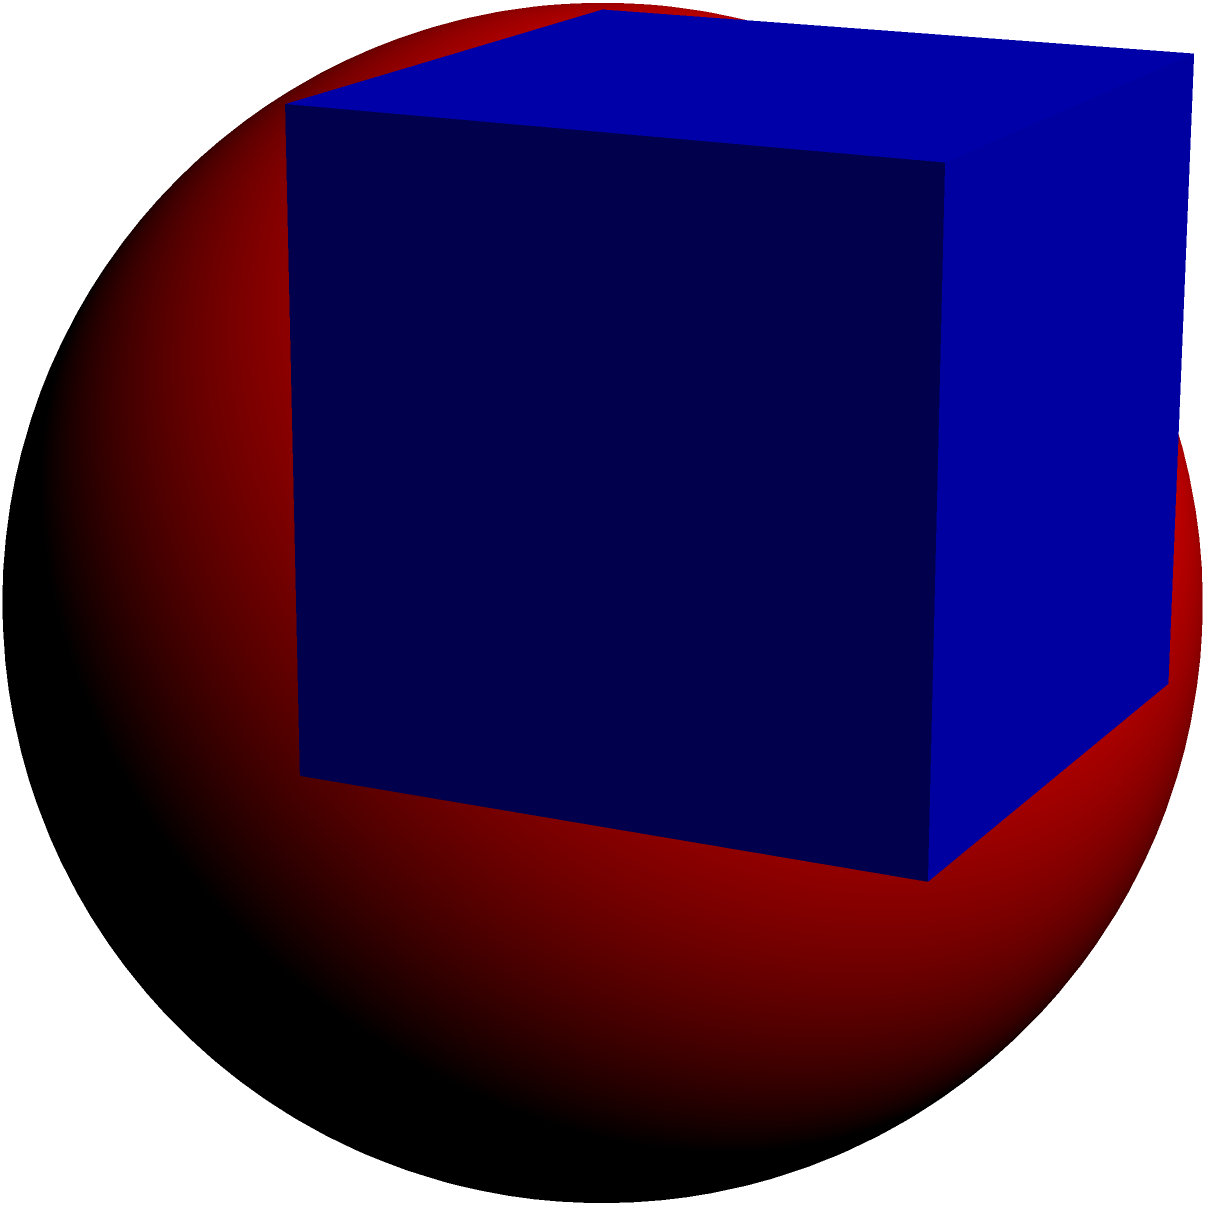As a programmer working on an interactive geometry module, you need to implement a function that calculates the volume of a sphere inscribed in a cube. Given that the edge length of the cube is 10 units, what is the volume of the inscribed sphere? Round your answer to two decimal places. Let's approach this step-by-step:

1) In a cube with an inscribed sphere, the diameter of the sphere is equal to the edge length of the cube. Therefore, the radius of the sphere is half the edge length of the cube.

2) Given: 
   Edge length of cube = 10 units
   Radius of sphere = 10/2 = 5 units

3) The formula for the volume of a sphere is:
   $$V = \frac{4}{3}\pi r^3$$

4) Substituting our radius:
   $$V = \frac{4}{3}\pi (5)^3$$

5) Simplify:
   $$V = \frac{4}{3}\pi (125)$$
   $$V = \frac{500}{3}\pi$$

6) Calculate (using π ≈ 3.14159):
   $$V \approx 523.5983 \text{ cubic units}$$

7) Rounding to two decimal places:
   $$V \approx 523.60 \text{ cubic units}$$
Answer: 523.60 cubic units 